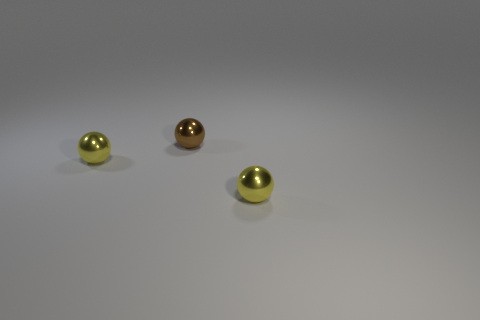Are there fewer gray cylinders than small brown shiny objects?
Provide a short and direct response. Yes. How many large objects are either yellow spheres or brown balls?
Give a very brief answer. 0. How many yellow shiny things are both right of the small brown ball and to the left of the small brown metallic object?
Ensure brevity in your answer.  0. Is the number of small brown spheres greater than the number of small yellow metallic objects?
Offer a very short reply. No. How many other objects are there of the same shape as the brown metallic thing?
Make the answer very short. 2. What size is the brown thing?
Provide a short and direct response. Small. There is a yellow thing to the left of the small metal ball on the right side of the brown sphere; how many tiny things are behind it?
Give a very brief answer. 1. There is a brown metal thing that is behind the yellow object that is on the right side of the brown ball; what is its shape?
Offer a terse response. Sphere. Are there any other things that are the same size as the brown metallic sphere?
Your answer should be very brief. Yes. There is a sphere that is to the right of the small brown object; what color is it?
Provide a succinct answer. Yellow. 